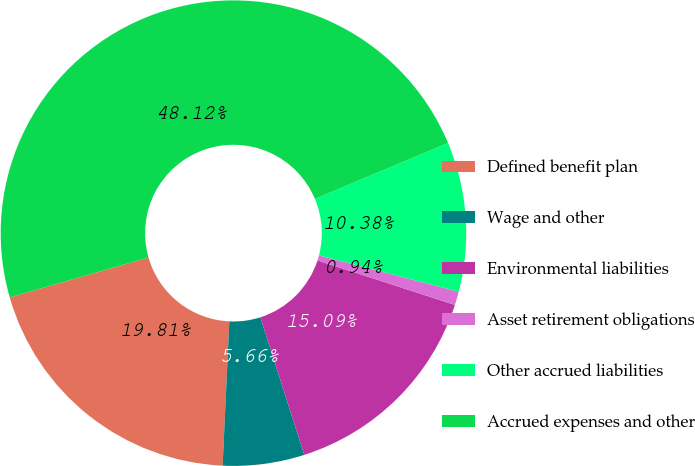<chart> <loc_0><loc_0><loc_500><loc_500><pie_chart><fcel>Defined benefit plan<fcel>Wage and other<fcel>Environmental liabilities<fcel>Asset retirement obligations<fcel>Other accrued liabilities<fcel>Accrued expenses and other<nl><fcel>19.81%<fcel>5.66%<fcel>15.09%<fcel>0.94%<fcel>10.38%<fcel>48.12%<nl></chart> 